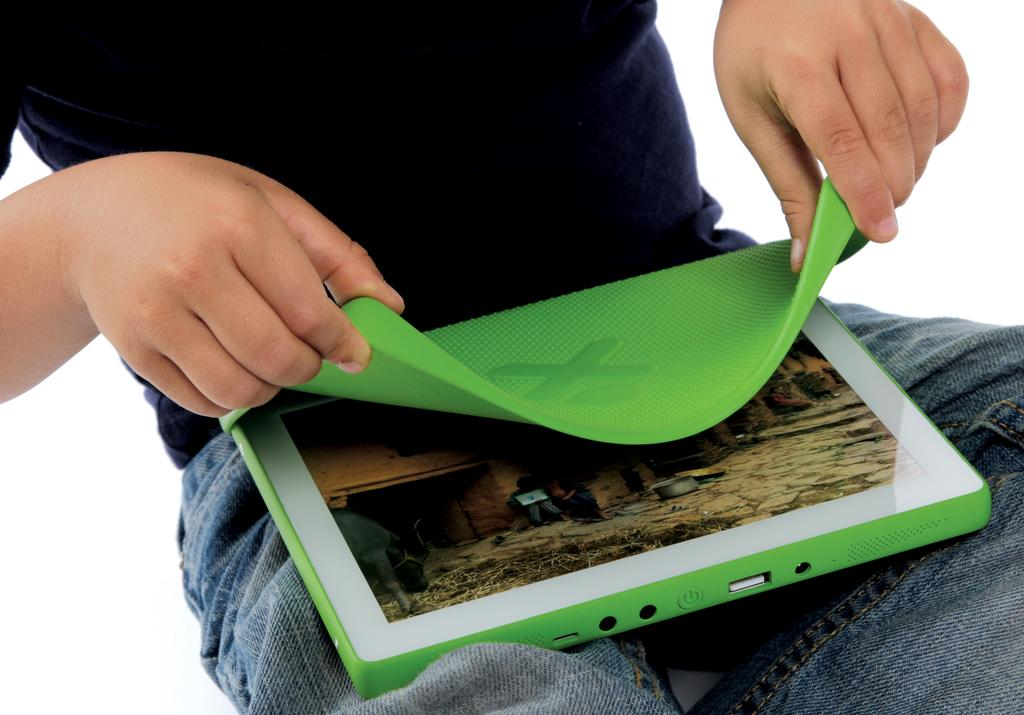Who is the main subject in the image? There is a man in the image. What is the man doing in the image? The man is sitting and holding a laptop. What is the man using to work or browse in the image? The man has a laptop on his lap. What is the color of the background in the image? The background of the image is white. What type of bell can be heard ringing in the image? There is no bell present or ringing in the image. What level of connection does the man have in the image? The image does not provide information about the man's internet connection or any other type of connection. 